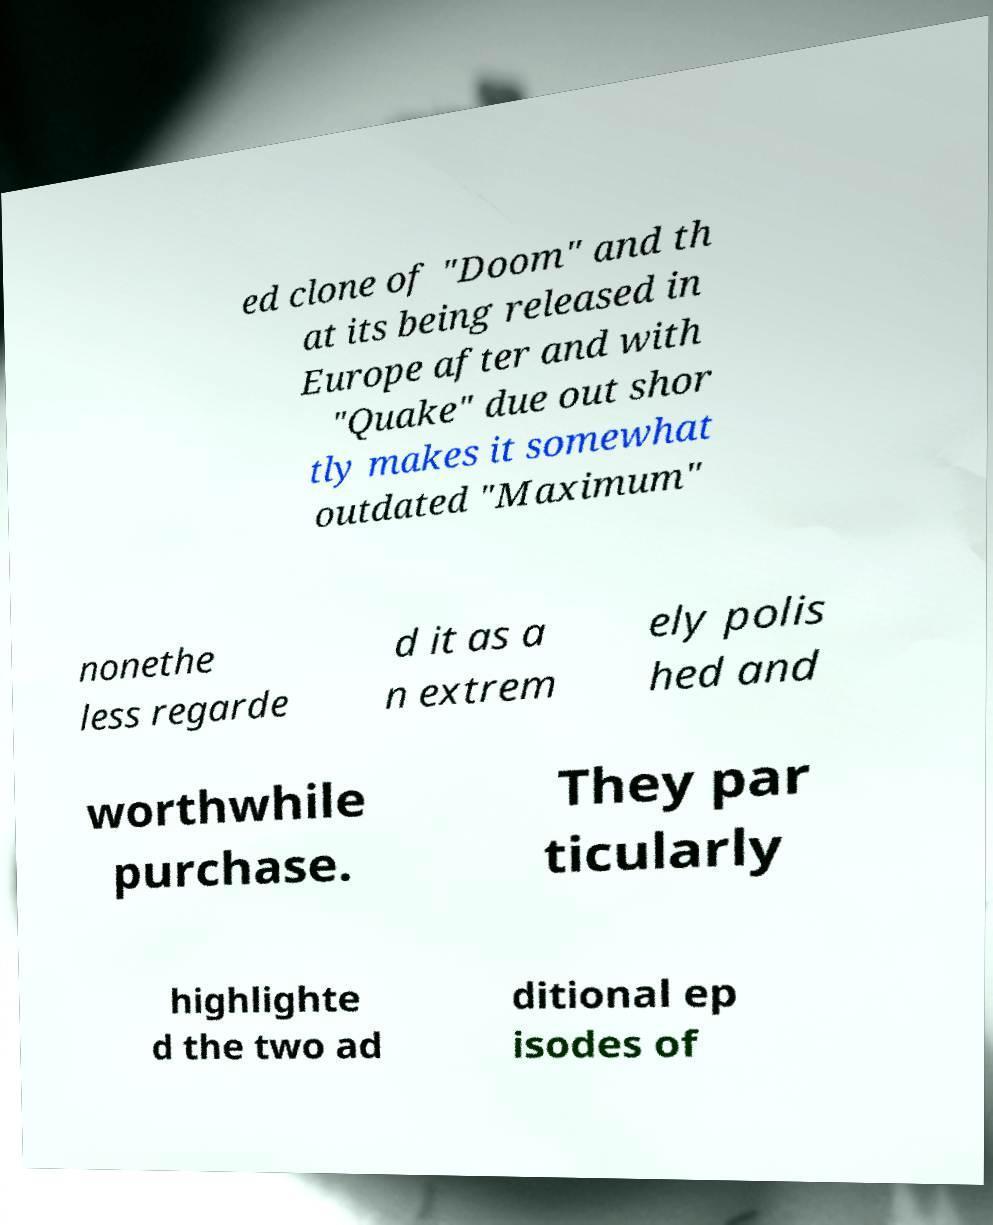There's text embedded in this image that I need extracted. Can you transcribe it verbatim? ed clone of "Doom" and th at its being released in Europe after and with "Quake" due out shor tly makes it somewhat outdated "Maximum" nonethe less regarde d it as a n extrem ely polis hed and worthwhile purchase. They par ticularly highlighte d the two ad ditional ep isodes of 